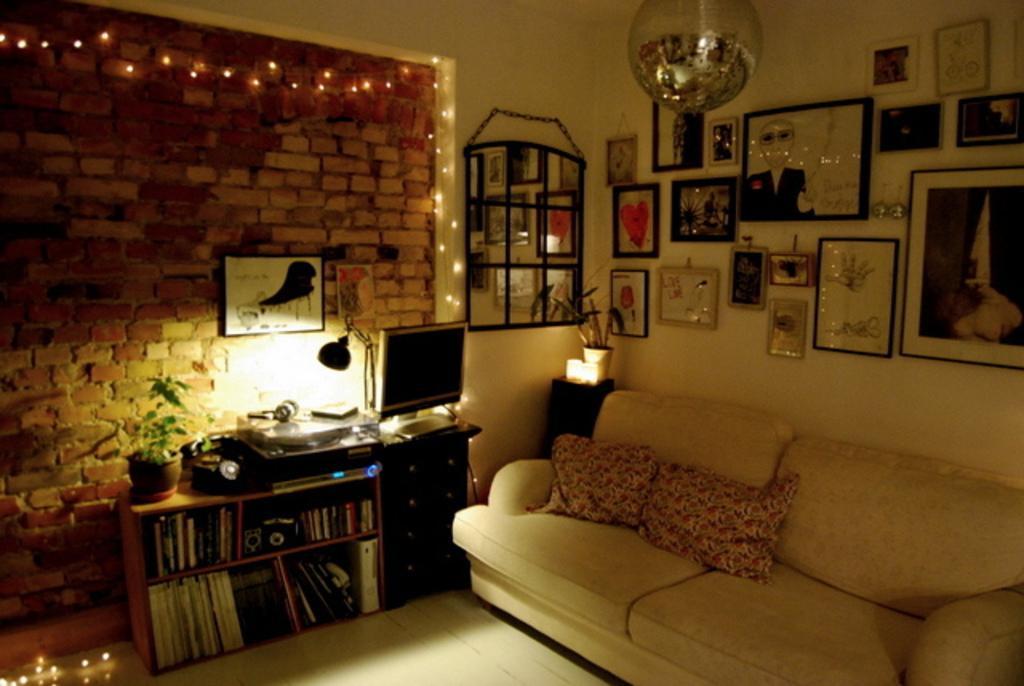Can you describe this image briefly? This picture shows a sofa and pillows. we see a monitor and photo frames on the wall and we see a plant and a bookshelf 